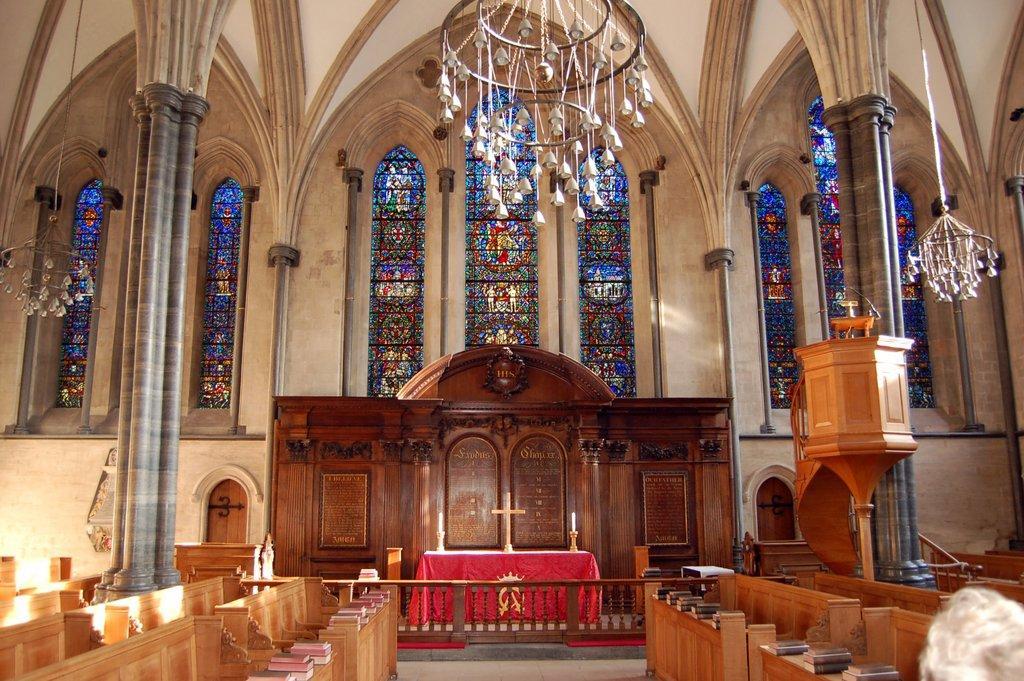Please provide a concise description of this image. This image is taken in a church. In the background there are a few walls, stained glasses and windows. At the top of the image there is a chandelier. In the middle of the image there are two pillars. There is a wooden work. There is a table with candle holders, candles and a cross symbol on it. There is a railing. There are a few objects. On the right side of the image there is a chandelier. At the bottom of the image there is a person and there are a few wooden works. 